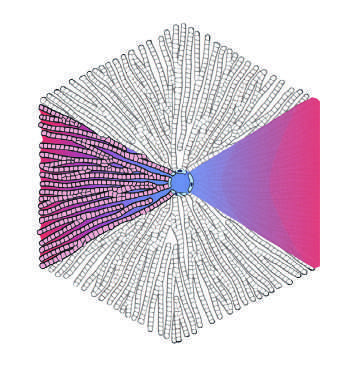do pathologists refer to the regions of the parenchyma as periportal and centrilobular?
Answer the question using a single word or phrase. Yes 